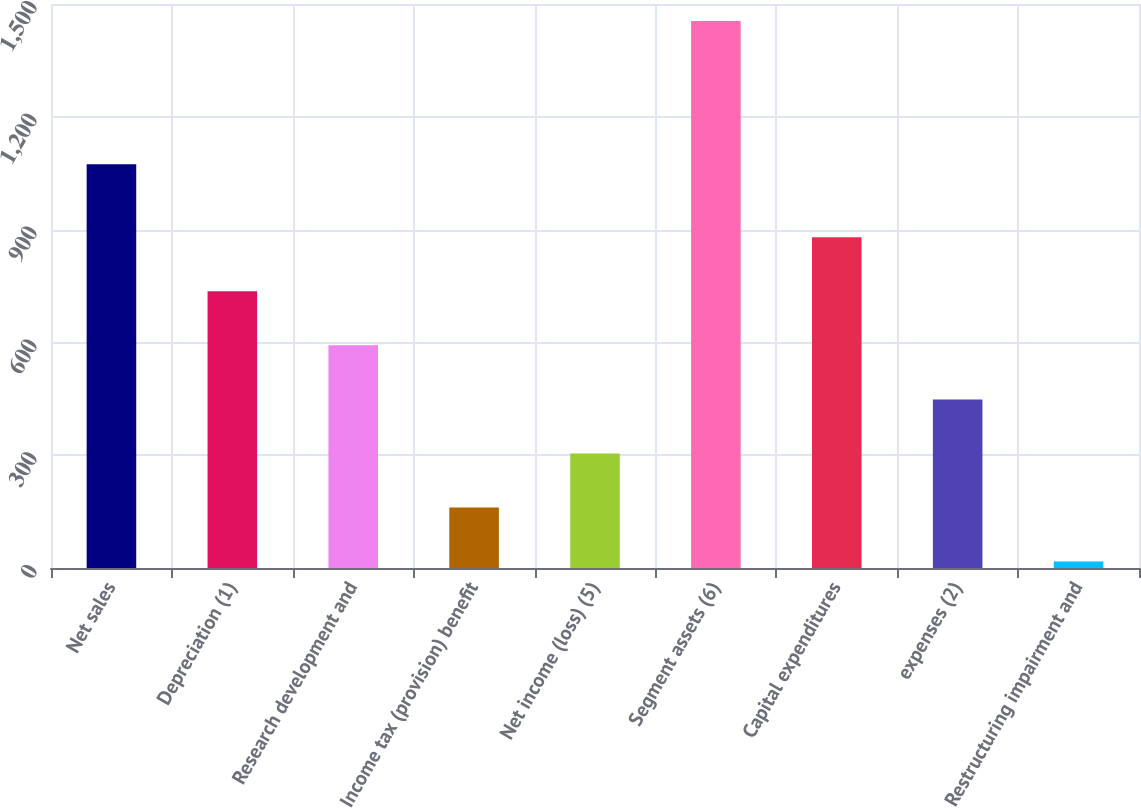<chart> <loc_0><loc_0><loc_500><loc_500><bar_chart><fcel>Net sales<fcel>Depreciation (1)<fcel>Research development and<fcel>Income tax (provision) benefit<fcel>Net income (loss) (5)<fcel>Segment assets (6)<fcel>Capital expenditures<fcel>expenses (2)<fcel>Restructuring impairment and<nl><fcel>1074<fcel>736<fcel>592.2<fcel>160.8<fcel>304.6<fcel>1455<fcel>879.8<fcel>448.4<fcel>17<nl></chart> 